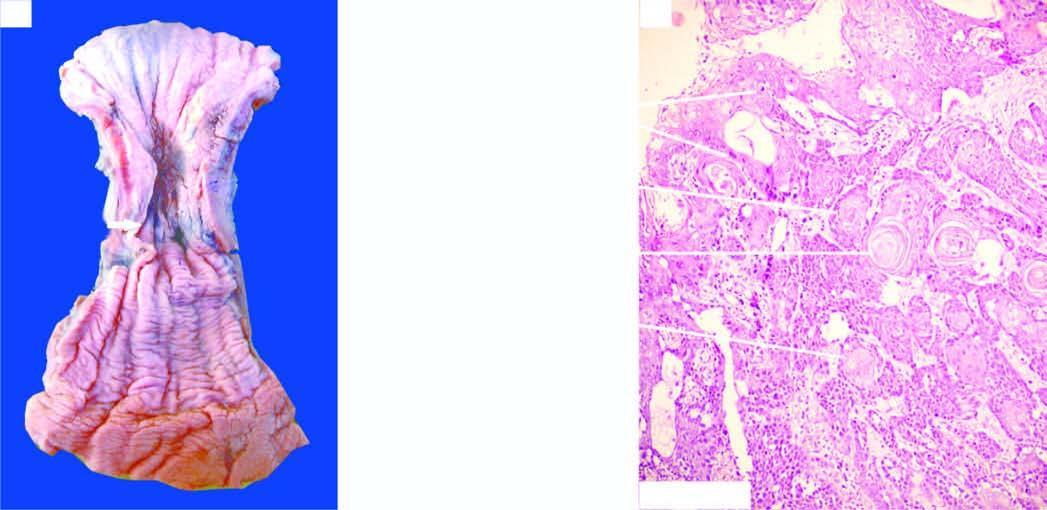what is ulcerated?
Answer the question using a single word or phrase. Mucosal surface 